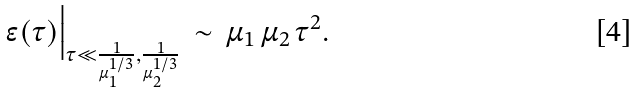<formula> <loc_0><loc_0><loc_500><loc_500>\epsilon ( \tau ) \Big | _ { \tau \ll \frac { 1 } { \mu _ { 1 } ^ { 1 / 3 } } , \frac { 1 } { \mu _ { 2 } ^ { 1 / 3 } } } \, \sim \, \mu _ { 1 } \, \mu _ { 2 } \, \tau ^ { 2 } .</formula> 